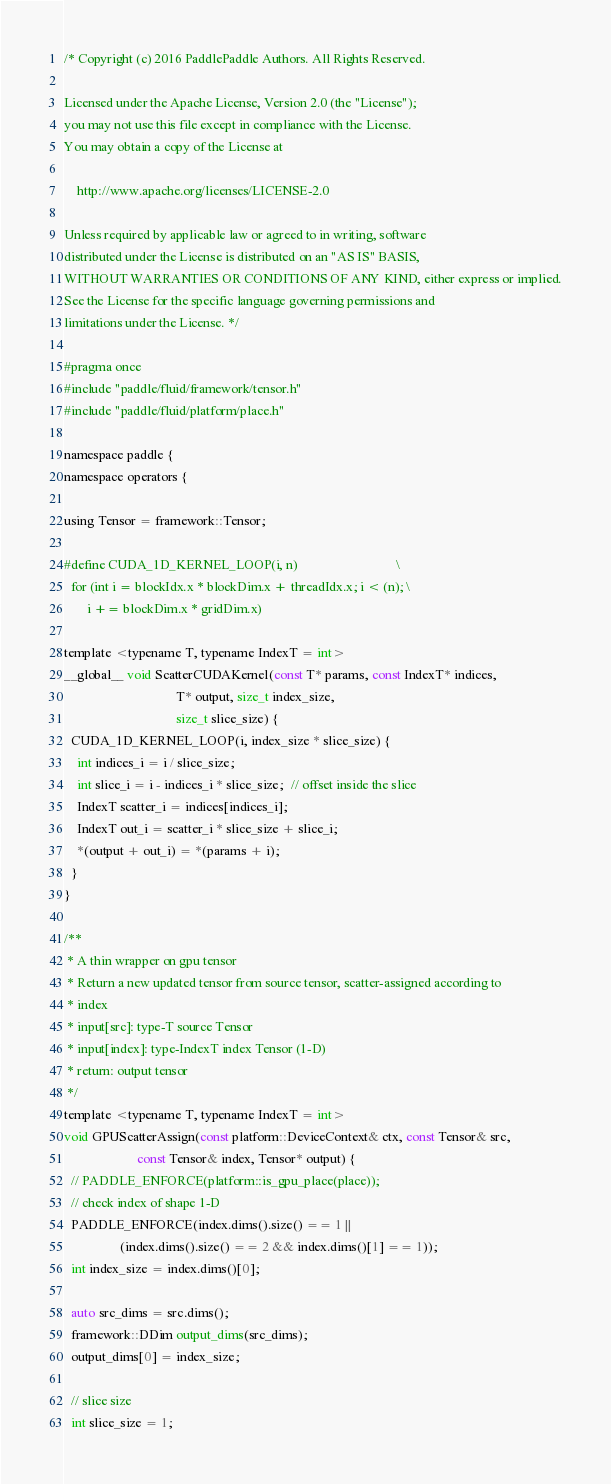<code> <loc_0><loc_0><loc_500><loc_500><_C_>/* Copyright (c) 2016 PaddlePaddle Authors. All Rights Reserved.

Licensed under the Apache License, Version 2.0 (the "License");
you may not use this file except in compliance with the License.
You may obtain a copy of the License at

    http://www.apache.org/licenses/LICENSE-2.0

Unless required by applicable law or agreed to in writing, software
distributed under the License is distributed on an "AS IS" BASIS,
WITHOUT WARRANTIES OR CONDITIONS OF ANY KIND, either express or implied.
See the License for the specific language governing permissions and
limitations under the License. */

#pragma once
#include "paddle/fluid/framework/tensor.h"
#include "paddle/fluid/platform/place.h"

namespace paddle {
namespace operators {

using Tensor = framework::Tensor;

#define CUDA_1D_KERNEL_LOOP(i, n)                              \
  for (int i = blockIdx.x * blockDim.x + threadIdx.x; i < (n); \
       i += blockDim.x * gridDim.x)

template <typename T, typename IndexT = int>
__global__ void ScatterCUDAKernel(const T* params, const IndexT* indices,
                                  T* output, size_t index_size,
                                  size_t slice_size) {
  CUDA_1D_KERNEL_LOOP(i, index_size * slice_size) {
    int indices_i = i / slice_size;
    int slice_i = i - indices_i * slice_size;  // offset inside the slice
    IndexT scatter_i = indices[indices_i];
    IndexT out_i = scatter_i * slice_size + slice_i;
    *(output + out_i) = *(params + i);
  }
}

/**
 * A thin wrapper on gpu tensor
 * Return a new updated tensor from source tensor, scatter-assigned according to
 * index
 * input[src]: type-T source Tensor
 * input[index]: type-IndexT index Tensor (1-D)
 * return: output tensor
 */
template <typename T, typename IndexT = int>
void GPUScatterAssign(const platform::DeviceContext& ctx, const Tensor& src,
                      const Tensor& index, Tensor* output) {
  // PADDLE_ENFORCE(platform::is_gpu_place(place));
  // check index of shape 1-D
  PADDLE_ENFORCE(index.dims().size() == 1 ||
                 (index.dims().size() == 2 && index.dims()[1] == 1));
  int index_size = index.dims()[0];

  auto src_dims = src.dims();
  framework::DDim output_dims(src_dims);
  output_dims[0] = index_size;

  // slice size
  int slice_size = 1;</code> 